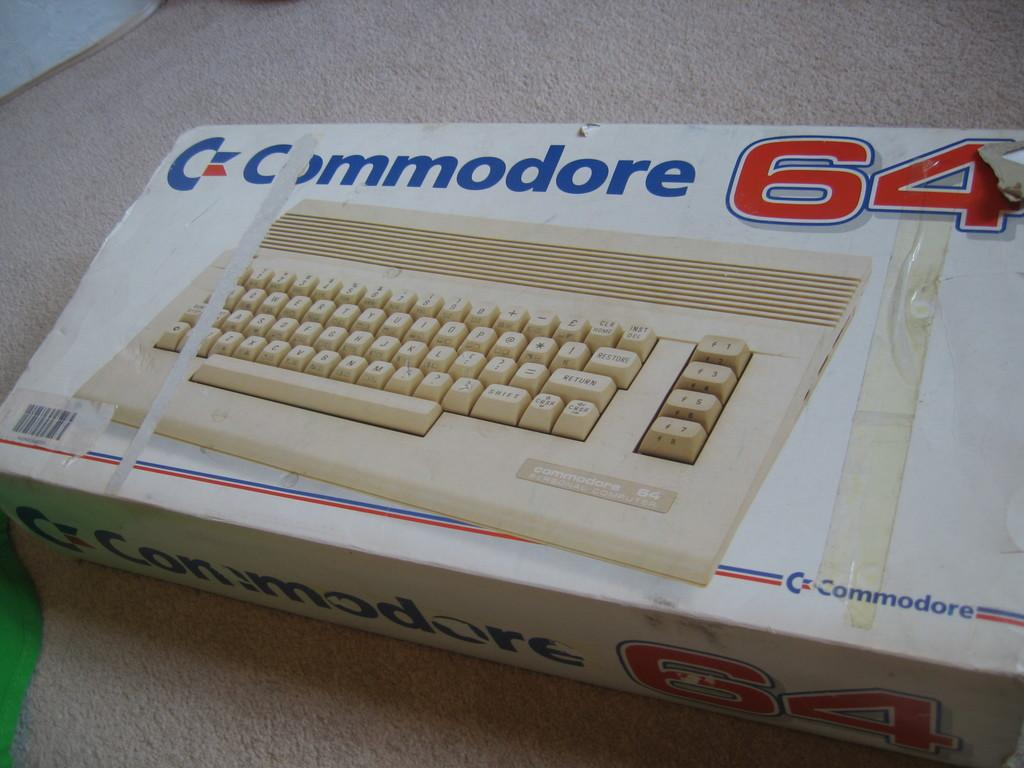<image>
Render a clear and concise summary of the photo. a box with the number 64 written at the top 